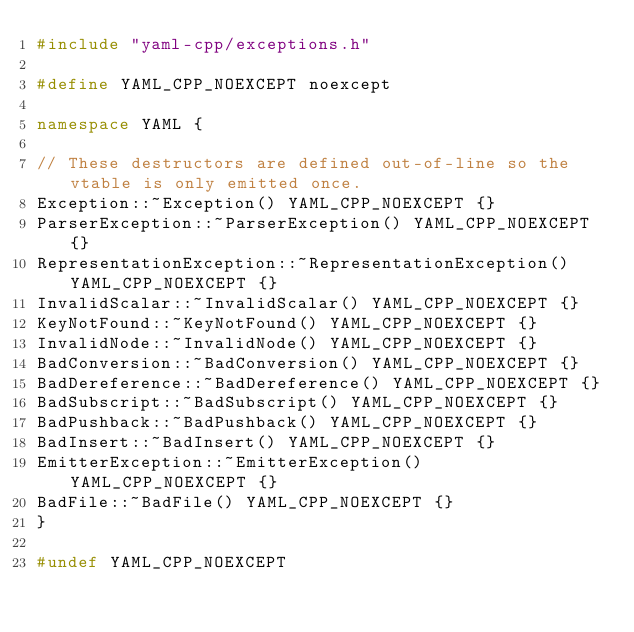Convert code to text. <code><loc_0><loc_0><loc_500><loc_500><_C++_>#include "yaml-cpp/exceptions.h"

#define YAML_CPP_NOEXCEPT noexcept

namespace YAML {

// These destructors are defined out-of-line so the vtable is only emitted once.
Exception::~Exception() YAML_CPP_NOEXCEPT {}
ParserException::~ParserException() YAML_CPP_NOEXCEPT {}
RepresentationException::~RepresentationException() YAML_CPP_NOEXCEPT {}
InvalidScalar::~InvalidScalar() YAML_CPP_NOEXCEPT {}
KeyNotFound::~KeyNotFound() YAML_CPP_NOEXCEPT {}
InvalidNode::~InvalidNode() YAML_CPP_NOEXCEPT {}
BadConversion::~BadConversion() YAML_CPP_NOEXCEPT {}
BadDereference::~BadDereference() YAML_CPP_NOEXCEPT {}
BadSubscript::~BadSubscript() YAML_CPP_NOEXCEPT {}
BadPushback::~BadPushback() YAML_CPP_NOEXCEPT {}
BadInsert::~BadInsert() YAML_CPP_NOEXCEPT {}
EmitterException::~EmitterException() YAML_CPP_NOEXCEPT {}
BadFile::~BadFile() YAML_CPP_NOEXCEPT {}
}

#undef YAML_CPP_NOEXCEPT


</code> 